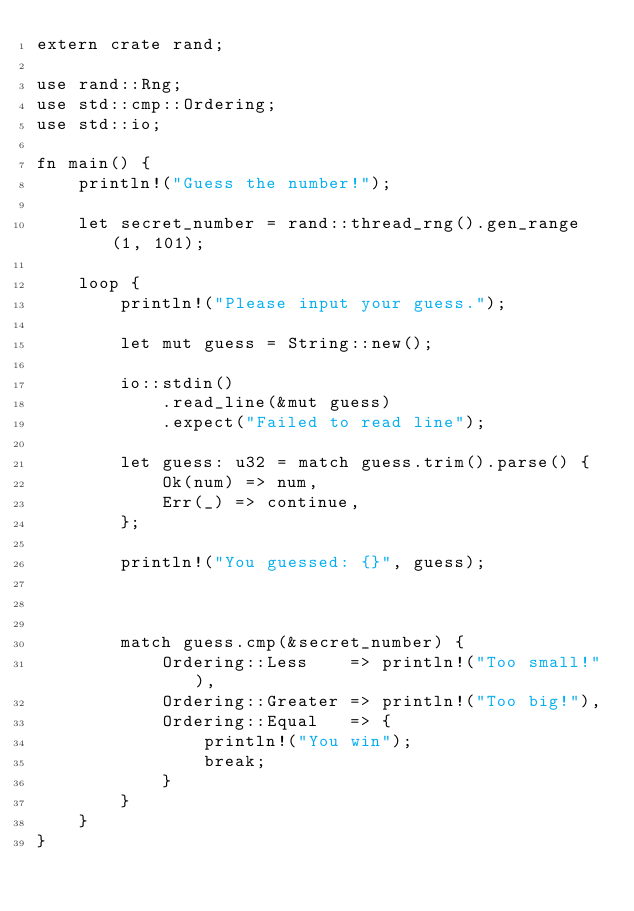Convert code to text. <code><loc_0><loc_0><loc_500><loc_500><_Rust_>extern crate rand;

use rand::Rng;
use std::cmp::Ordering;
use std::io;

fn main() {
    println!("Guess the number!");

    let secret_number = rand::thread_rng().gen_range(1, 101);

    loop {
        println!("Please input your guess.");

        let mut guess = String::new();

        io::stdin()
            .read_line(&mut guess)
            .expect("Failed to read line");

        let guess: u32 = match guess.trim().parse() {
            Ok(num) => num,
            Err(_) => continue,
        };

        println!("You guessed: {}", guess);



        match guess.cmp(&secret_number) {
            Ordering::Less    => println!("Too small!"),
            Ordering::Greater => println!("Too big!"),
            Ordering::Equal   => {
                println!("You win");
                break;
            }
        }
    }
}
</code> 